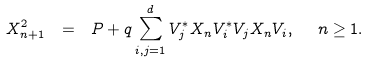<formula> <loc_0><loc_0><loc_500><loc_500>X _ { n + 1 } ^ { 2 } \ = \ P + q \sum _ { i , j = 1 } ^ { d } V _ { j } ^ { * } X _ { n } V _ { i } ^ { * } V _ { j } X _ { n } V _ { i } , \ \ n \geq 1 .</formula> 